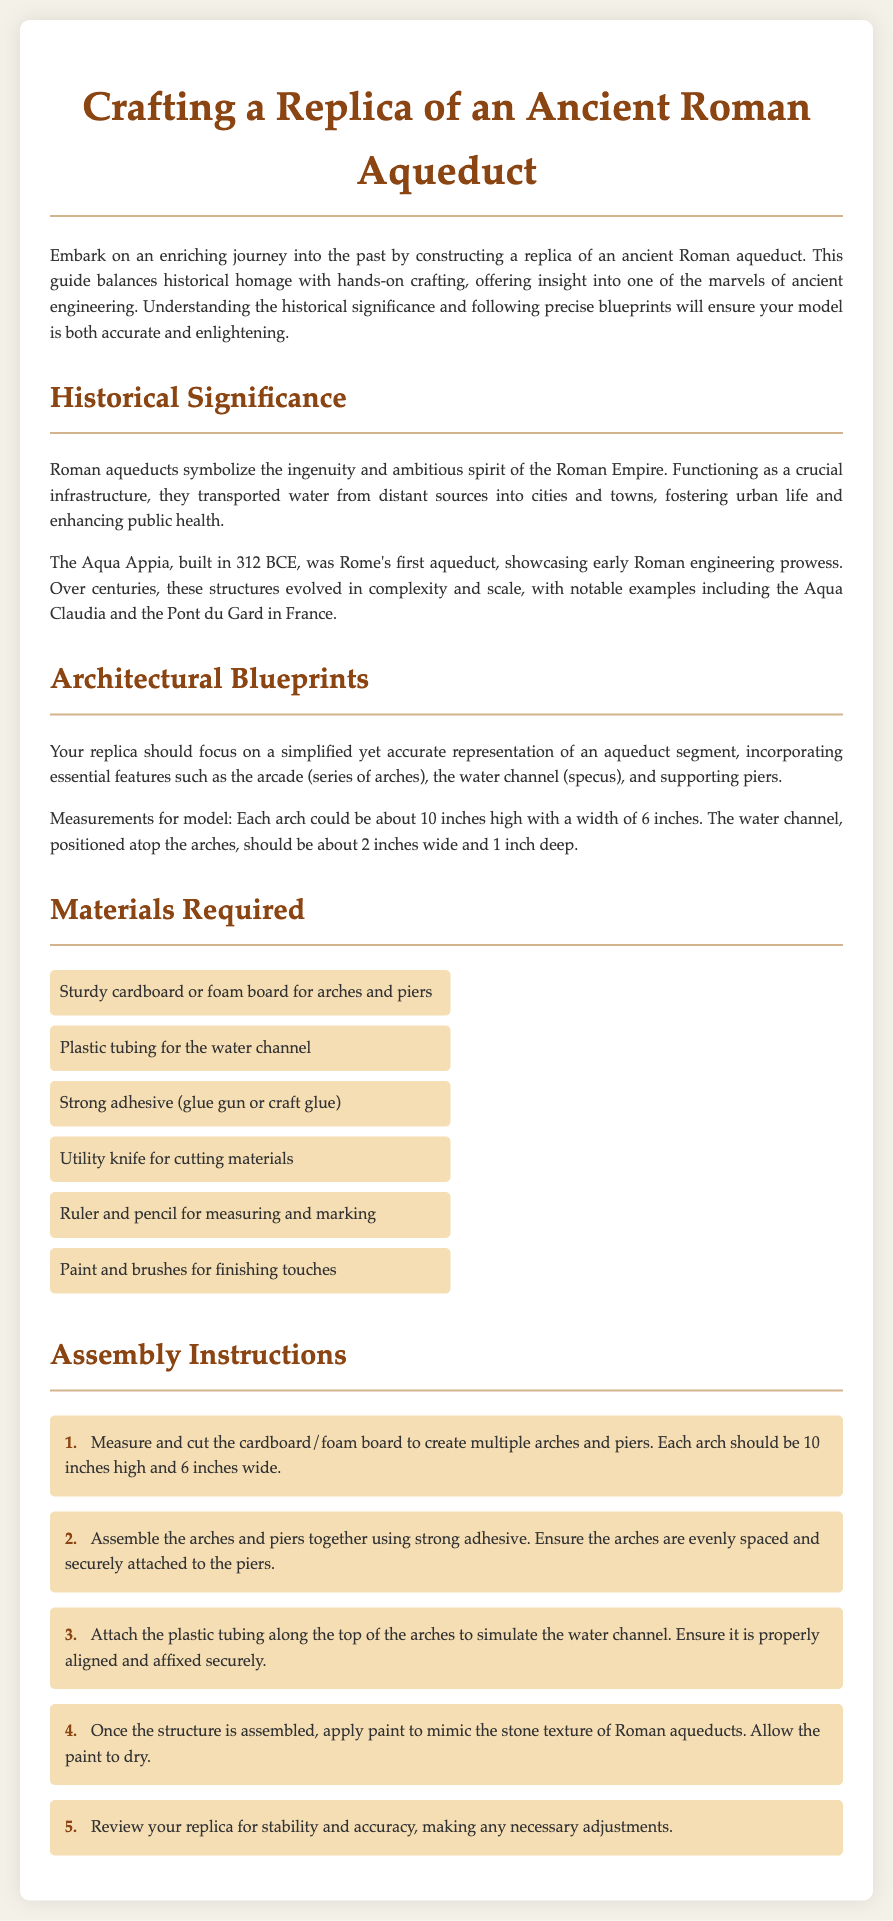what is the first aqueduct built in Rome? The document mentions that Aqua Appia, built in 312 BCE, was Rome's first aqueduct.
Answer: Aqua Appia how high should each arch be in the replica? The instructions specify that each arch should be about 10 inches high.
Answer: 10 inches what materials are needed for the water channel? The document lists plastic tubing as the material required for the water channel.
Answer: Plastic tubing how many steps are listed in the assembly instructions? The assembly section provides five distinct steps for crafting the replica.
Answer: 5 what should be used for cutting materials? The document states that a utility knife is required for cutting materials.
Answer: Utility knife why were Roman aqueducts significant? The document explains that Roman aqueducts symbolized ingenuity and fostered urban life.
Answer: Ingenuity and urban life what is the width of the water channel in the model? The document specifies that the water channel should be about 2 inches wide.
Answer: 2 inches 